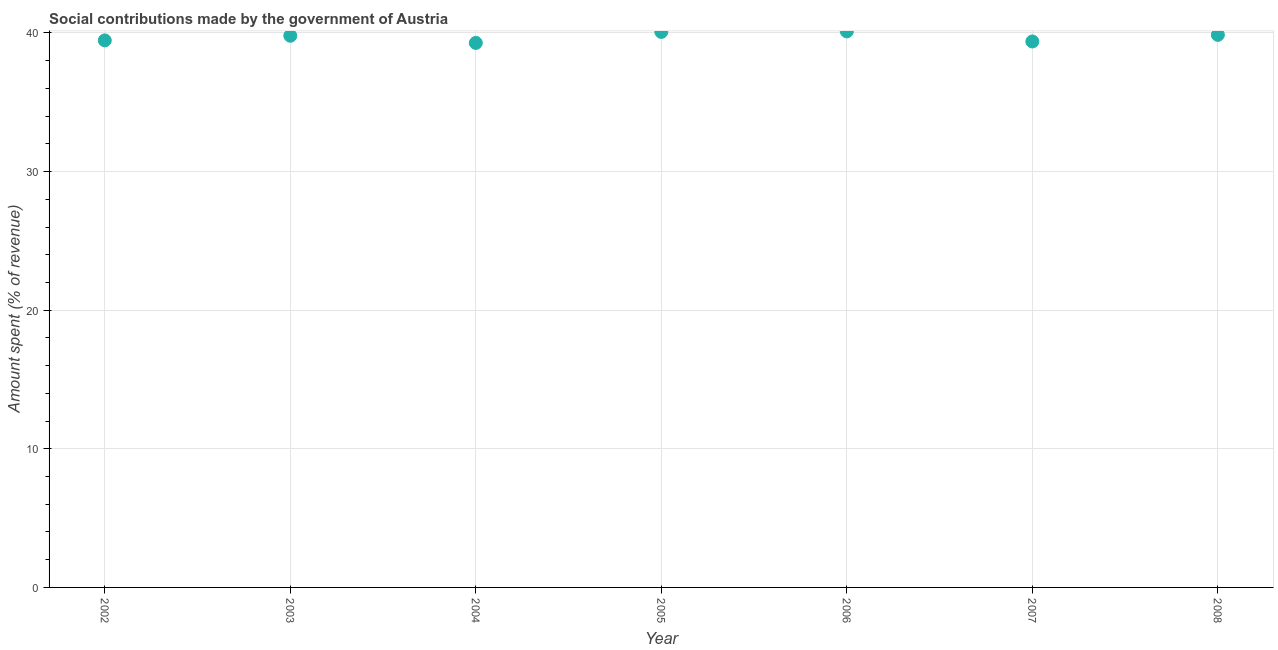What is the amount spent in making social contributions in 2005?
Ensure brevity in your answer.  40.08. Across all years, what is the maximum amount spent in making social contributions?
Offer a very short reply. 40.11. Across all years, what is the minimum amount spent in making social contributions?
Keep it short and to the point. 39.28. In which year was the amount spent in making social contributions maximum?
Offer a terse response. 2006. In which year was the amount spent in making social contributions minimum?
Offer a very short reply. 2004. What is the sum of the amount spent in making social contributions?
Your answer should be very brief. 277.98. What is the difference between the amount spent in making social contributions in 2004 and 2008?
Give a very brief answer. -0.58. What is the average amount spent in making social contributions per year?
Offer a terse response. 39.71. What is the median amount spent in making social contributions?
Your answer should be compact. 39.8. In how many years, is the amount spent in making social contributions greater than 20 %?
Keep it short and to the point. 7. What is the ratio of the amount spent in making social contributions in 2004 to that in 2007?
Provide a short and direct response. 1. Is the amount spent in making social contributions in 2002 less than that in 2004?
Give a very brief answer. No. What is the difference between the highest and the second highest amount spent in making social contributions?
Keep it short and to the point. 0.04. Is the sum of the amount spent in making social contributions in 2004 and 2007 greater than the maximum amount spent in making social contributions across all years?
Provide a short and direct response. Yes. What is the difference between the highest and the lowest amount spent in making social contributions?
Provide a short and direct response. 0.83. In how many years, is the amount spent in making social contributions greater than the average amount spent in making social contributions taken over all years?
Your response must be concise. 4. Does the amount spent in making social contributions monotonically increase over the years?
Your answer should be compact. No. Are the values on the major ticks of Y-axis written in scientific E-notation?
Provide a succinct answer. No. What is the title of the graph?
Provide a short and direct response. Social contributions made by the government of Austria. What is the label or title of the X-axis?
Your answer should be compact. Year. What is the label or title of the Y-axis?
Make the answer very short. Amount spent (% of revenue). What is the Amount spent (% of revenue) in 2002?
Your answer should be very brief. 39.46. What is the Amount spent (% of revenue) in 2003?
Keep it short and to the point. 39.8. What is the Amount spent (% of revenue) in 2004?
Your answer should be very brief. 39.28. What is the Amount spent (% of revenue) in 2005?
Your answer should be compact. 40.08. What is the Amount spent (% of revenue) in 2006?
Keep it short and to the point. 40.11. What is the Amount spent (% of revenue) in 2007?
Your response must be concise. 39.39. What is the Amount spent (% of revenue) in 2008?
Offer a very short reply. 39.86. What is the difference between the Amount spent (% of revenue) in 2002 and 2003?
Provide a succinct answer. -0.34. What is the difference between the Amount spent (% of revenue) in 2002 and 2004?
Your answer should be compact. 0.18. What is the difference between the Amount spent (% of revenue) in 2002 and 2005?
Make the answer very short. -0.61. What is the difference between the Amount spent (% of revenue) in 2002 and 2006?
Offer a terse response. -0.65. What is the difference between the Amount spent (% of revenue) in 2002 and 2007?
Your response must be concise. 0.08. What is the difference between the Amount spent (% of revenue) in 2002 and 2008?
Your answer should be very brief. -0.4. What is the difference between the Amount spent (% of revenue) in 2003 and 2004?
Your answer should be compact. 0.52. What is the difference between the Amount spent (% of revenue) in 2003 and 2005?
Your answer should be compact. -0.28. What is the difference between the Amount spent (% of revenue) in 2003 and 2006?
Make the answer very short. -0.31. What is the difference between the Amount spent (% of revenue) in 2003 and 2007?
Make the answer very short. 0.41. What is the difference between the Amount spent (% of revenue) in 2003 and 2008?
Make the answer very short. -0.06. What is the difference between the Amount spent (% of revenue) in 2004 and 2005?
Ensure brevity in your answer.  -0.79. What is the difference between the Amount spent (% of revenue) in 2004 and 2006?
Your response must be concise. -0.83. What is the difference between the Amount spent (% of revenue) in 2004 and 2007?
Give a very brief answer. -0.1. What is the difference between the Amount spent (% of revenue) in 2004 and 2008?
Make the answer very short. -0.58. What is the difference between the Amount spent (% of revenue) in 2005 and 2006?
Your answer should be compact. -0.04. What is the difference between the Amount spent (% of revenue) in 2005 and 2007?
Your answer should be compact. 0.69. What is the difference between the Amount spent (% of revenue) in 2005 and 2008?
Offer a terse response. 0.21. What is the difference between the Amount spent (% of revenue) in 2006 and 2007?
Provide a succinct answer. 0.73. What is the difference between the Amount spent (% of revenue) in 2006 and 2008?
Make the answer very short. 0.25. What is the difference between the Amount spent (% of revenue) in 2007 and 2008?
Offer a very short reply. -0.48. What is the ratio of the Amount spent (% of revenue) in 2002 to that in 2003?
Offer a very short reply. 0.99. What is the ratio of the Amount spent (% of revenue) in 2002 to that in 2007?
Your response must be concise. 1. What is the ratio of the Amount spent (% of revenue) in 2003 to that in 2005?
Make the answer very short. 0.99. What is the ratio of the Amount spent (% of revenue) in 2003 to that in 2006?
Provide a succinct answer. 0.99. What is the ratio of the Amount spent (% of revenue) in 2003 to that in 2008?
Your answer should be compact. 1. What is the ratio of the Amount spent (% of revenue) in 2004 to that in 2008?
Provide a succinct answer. 0.98. What is the ratio of the Amount spent (% of revenue) in 2005 to that in 2006?
Give a very brief answer. 1. What is the ratio of the Amount spent (% of revenue) in 2005 to that in 2007?
Provide a short and direct response. 1.02. What is the ratio of the Amount spent (% of revenue) in 2005 to that in 2008?
Your answer should be very brief. 1. What is the ratio of the Amount spent (% of revenue) in 2006 to that in 2007?
Ensure brevity in your answer.  1.02. What is the ratio of the Amount spent (% of revenue) in 2006 to that in 2008?
Give a very brief answer. 1.01. What is the ratio of the Amount spent (% of revenue) in 2007 to that in 2008?
Offer a very short reply. 0.99. 